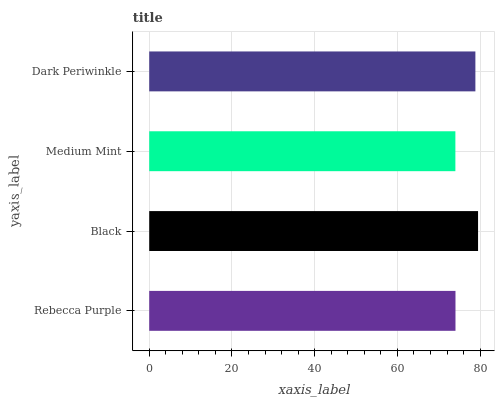Is Medium Mint the minimum?
Answer yes or no. Yes. Is Black the maximum?
Answer yes or no. Yes. Is Black the minimum?
Answer yes or no. No. Is Medium Mint the maximum?
Answer yes or no. No. Is Black greater than Medium Mint?
Answer yes or no. Yes. Is Medium Mint less than Black?
Answer yes or no. Yes. Is Medium Mint greater than Black?
Answer yes or no. No. Is Black less than Medium Mint?
Answer yes or no. No. Is Dark Periwinkle the high median?
Answer yes or no. Yes. Is Rebecca Purple the low median?
Answer yes or no. Yes. Is Black the high median?
Answer yes or no. No. Is Medium Mint the low median?
Answer yes or no. No. 